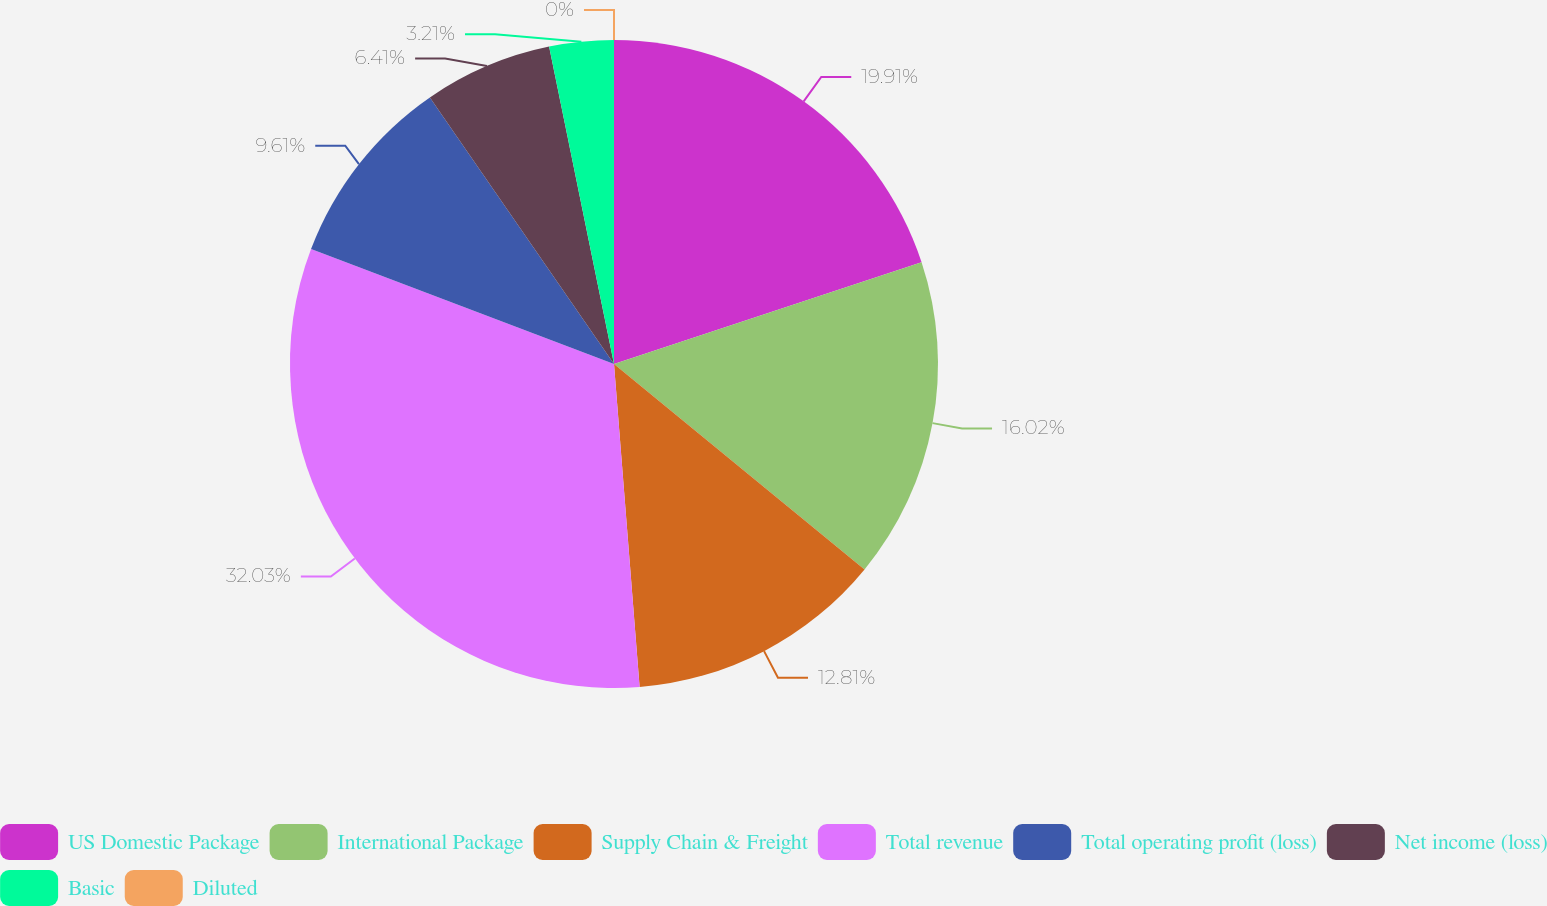Convert chart. <chart><loc_0><loc_0><loc_500><loc_500><pie_chart><fcel>US Domestic Package<fcel>International Package<fcel>Supply Chain & Freight<fcel>Total revenue<fcel>Total operating profit (loss)<fcel>Net income (loss)<fcel>Basic<fcel>Diluted<nl><fcel>19.91%<fcel>16.02%<fcel>12.81%<fcel>32.03%<fcel>9.61%<fcel>6.41%<fcel>3.21%<fcel>0.0%<nl></chart> 